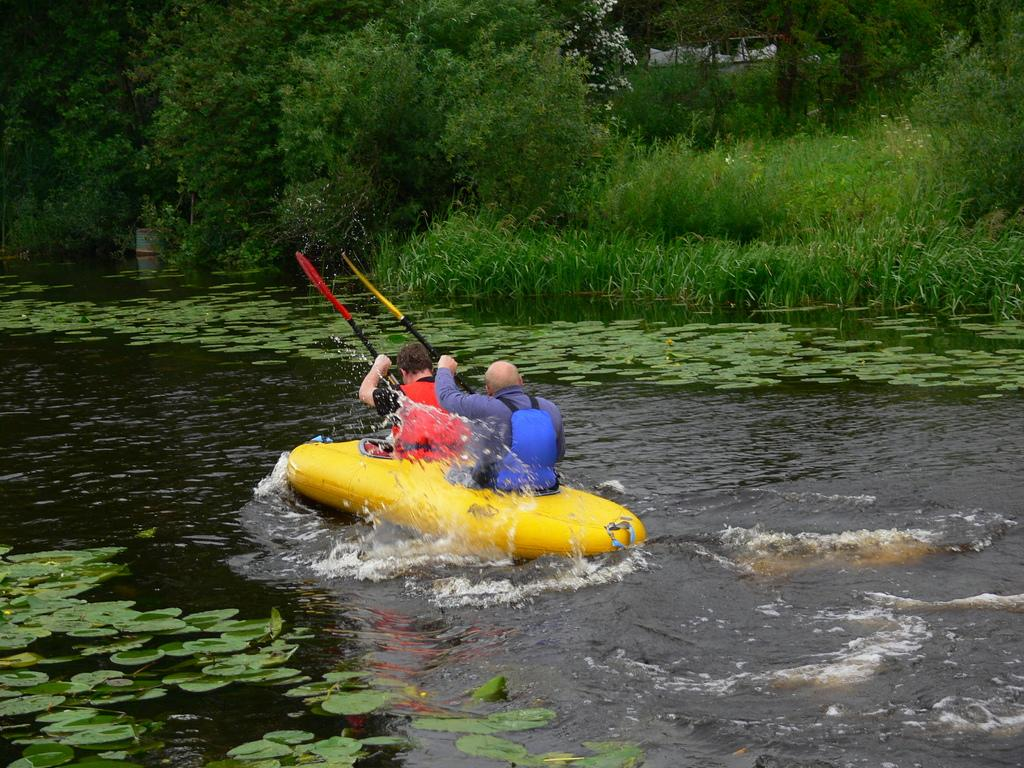How many people are in the image? There are two people in the image. What are the two people doing in the image? The two people are riding an inflatable boat. Where is the boat located? The boat is on a river. What can be seen in the background of the image? There are trees visible in the background of the image. Can you tell me how many dolls are being pulled by the boat in the image? There are no dolls present in the image; the two people are riding an inflatable boat on a river. 